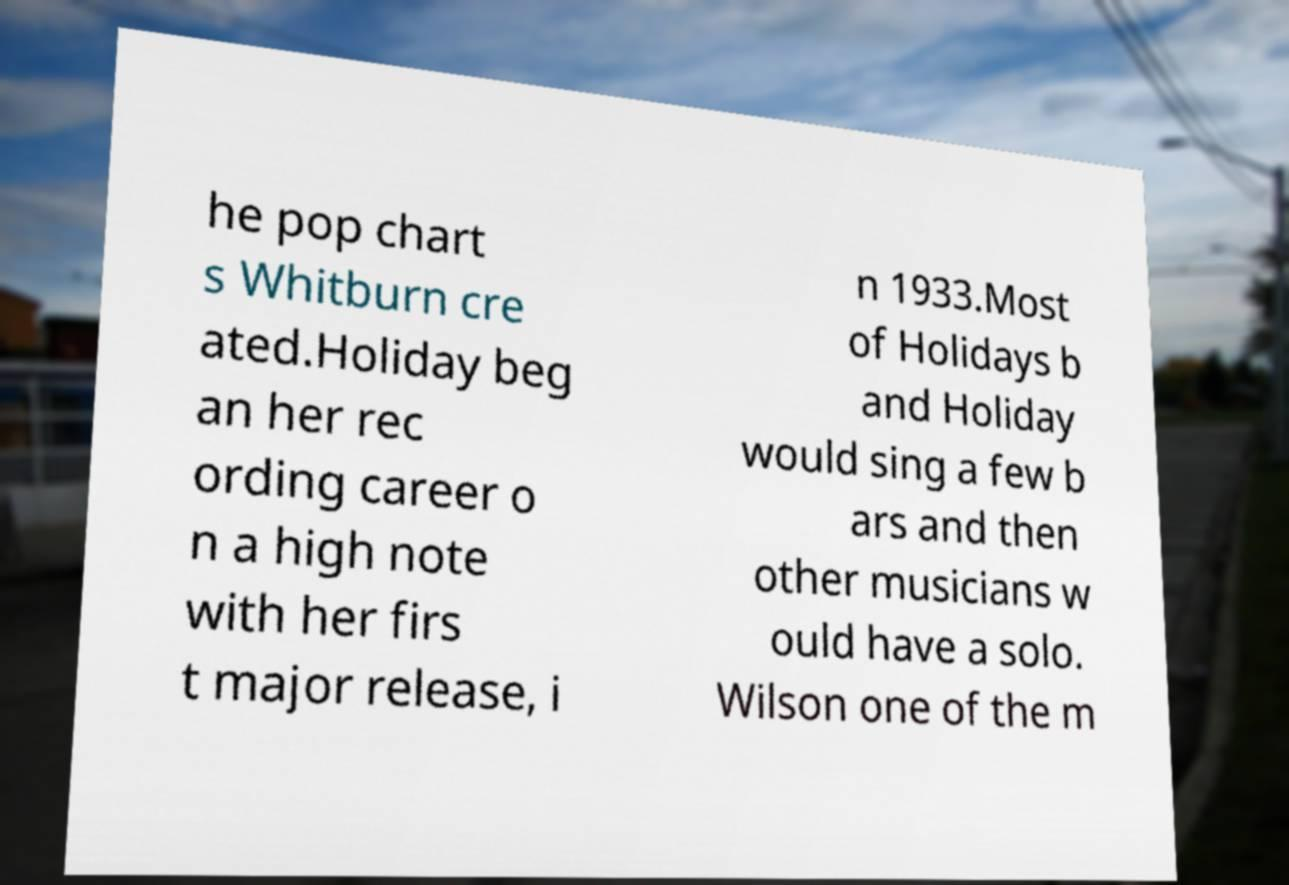Could you assist in decoding the text presented in this image and type it out clearly? he pop chart s Whitburn cre ated.Holiday beg an her rec ording career o n a high note with her firs t major release, i n 1933.Most of Holidays b and Holiday would sing a few b ars and then other musicians w ould have a solo. Wilson one of the m 